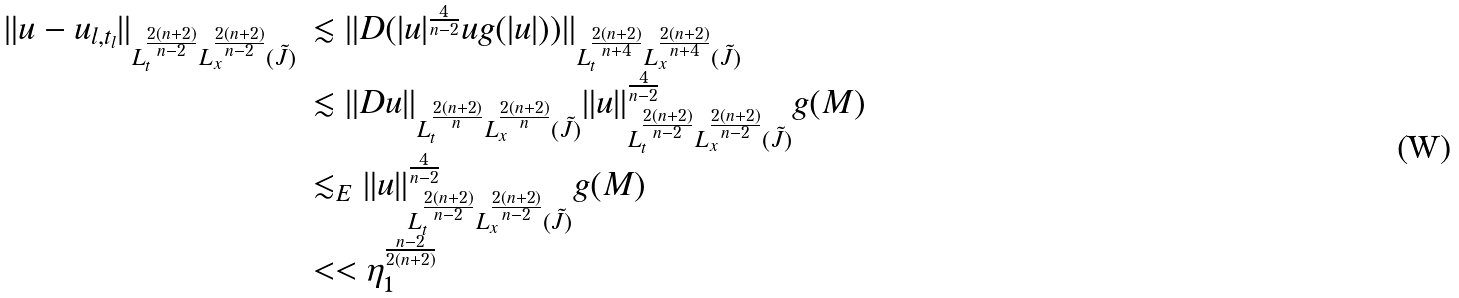<formula> <loc_0><loc_0><loc_500><loc_500>\begin{array} { l l } \| u - u _ { l , t _ { l } } \| _ { L _ { t } ^ { \frac { 2 ( n + 2 ) } { n - 2 } } L _ { x } ^ { \frac { 2 ( n + 2 ) } { n - 2 } } ( \tilde { J } ) } & \lesssim \| D ( | u | ^ { \frac { 4 } { n - 2 } } u g ( | u | ) ) \| _ { L _ { t } ^ { \frac { 2 ( n + 2 ) } { n + 4 } } L _ { x } ^ { \frac { 2 ( n + 2 ) } { n + 4 } } ( \tilde { J } ) } \\ & \lesssim \| D u \| _ { L _ { t } ^ { \frac { 2 ( n + 2 ) } { n } } L _ { x } ^ { \frac { 2 ( n + 2 ) } { n } } ( \tilde { J } ) } \| u \| _ { L _ { t } ^ { \frac { 2 ( n + 2 ) } { n - 2 } } L _ { x } ^ { \frac { 2 ( n + 2 ) } { n - 2 } } ( \tilde { J } ) } ^ { \frac { 4 } { n - 2 } } g ( M ) \\ & \lesssim _ { E } \| u \| _ { L _ { t } ^ { \frac { 2 ( n + 2 ) } { n - 2 } } L _ { x } ^ { \frac { 2 ( n + 2 ) } { n - 2 } } ( \tilde { J } ) } ^ { \frac { 4 } { n - 2 } } g ( M ) \\ & < < \eta _ { 1 } ^ { \frac { n - 2 } { 2 ( n + 2 ) } } \end{array}</formula> 